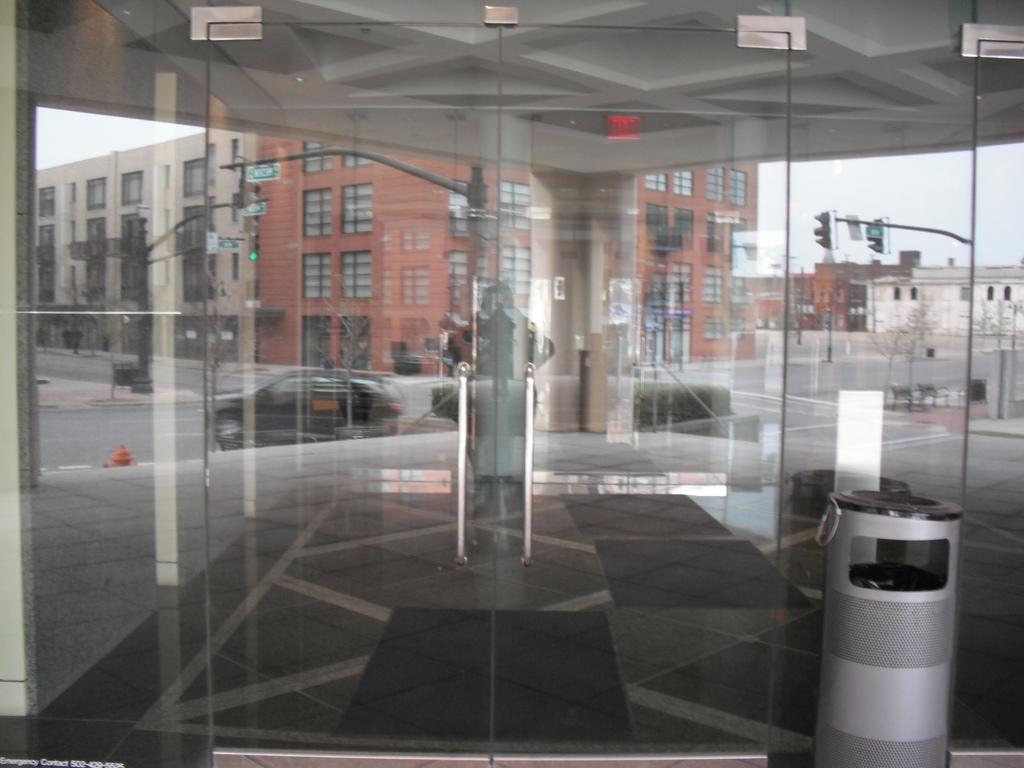Can you describe this image briefly? In this picture I can see glass door through it we can see buildings, road, signal lights. 